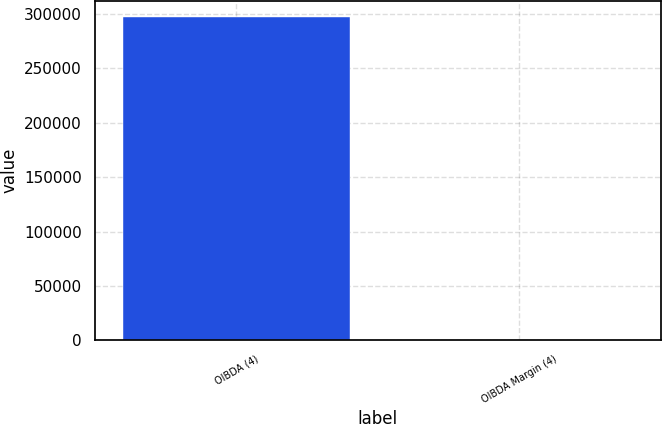Convert chart. <chart><loc_0><loc_0><loc_500><loc_500><bar_chart><fcel>OIBDA (4)<fcel>OIBDA Margin (4)<nl><fcel>297387<fcel>25.1<nl></chart> 